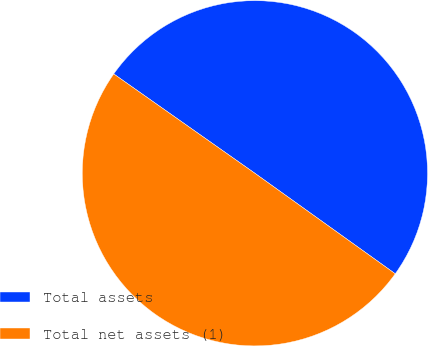Convert chart to OTSL. <chart><loc_0><loc_0><loc_500><loc_500><pie_chart><fcel>Total assets<fcel>Total net assets (1)<nl><fcel>50.13%<fcel>49.87%<nl></chart> 